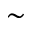<formula> <loc_0><loc_0><loc_500><loc_500>\sim</formula> 